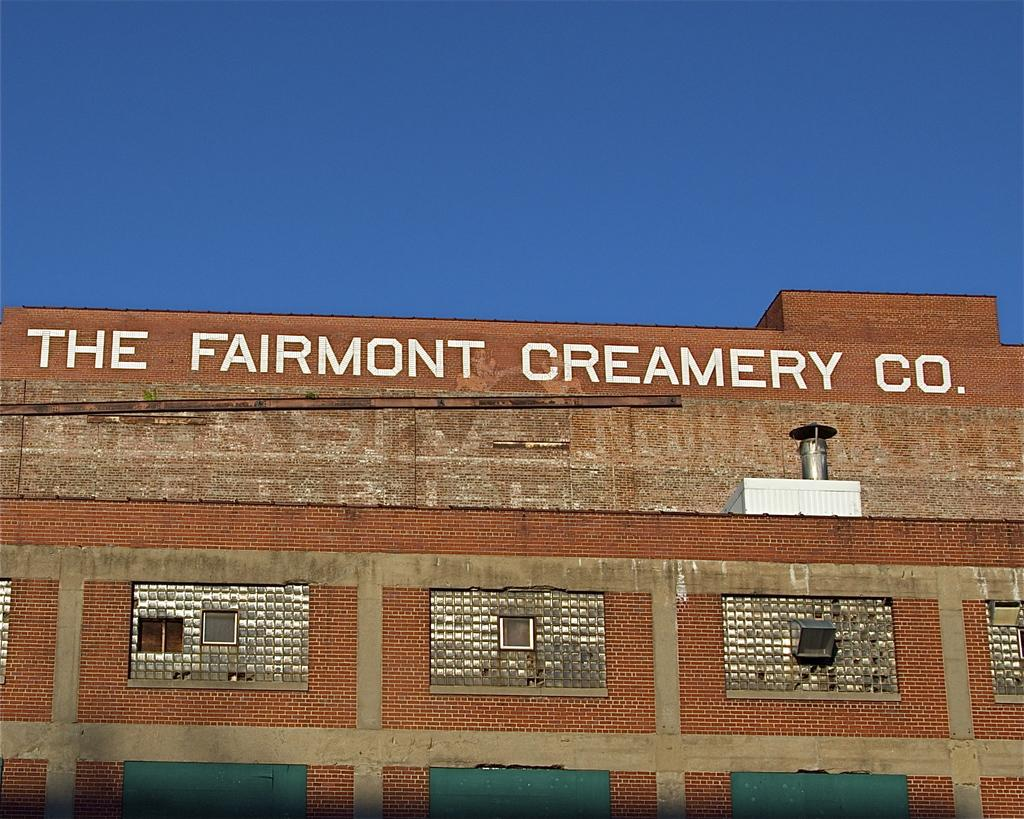What type of structure is present in the image? There is a building in the image. Is there any text or signage on the building? Yes, there is a name on the top of the building. What can be seen in the background of the image? The sky is visible at the top of the image. What type of hammer is being used to destroy the building in the image? There is no hammer or destruction present in the image; it simply shows a building with a name on top. What emotion is being expressed by the building in the image? Buildings do not express emotions; they are inanimate objects. 